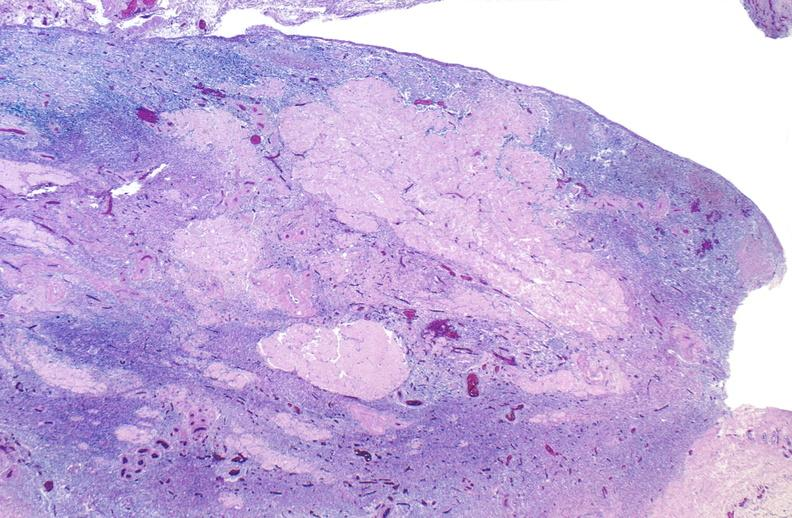does this image show normal ovary?
Answer the question using a single word or phrase. Yes 